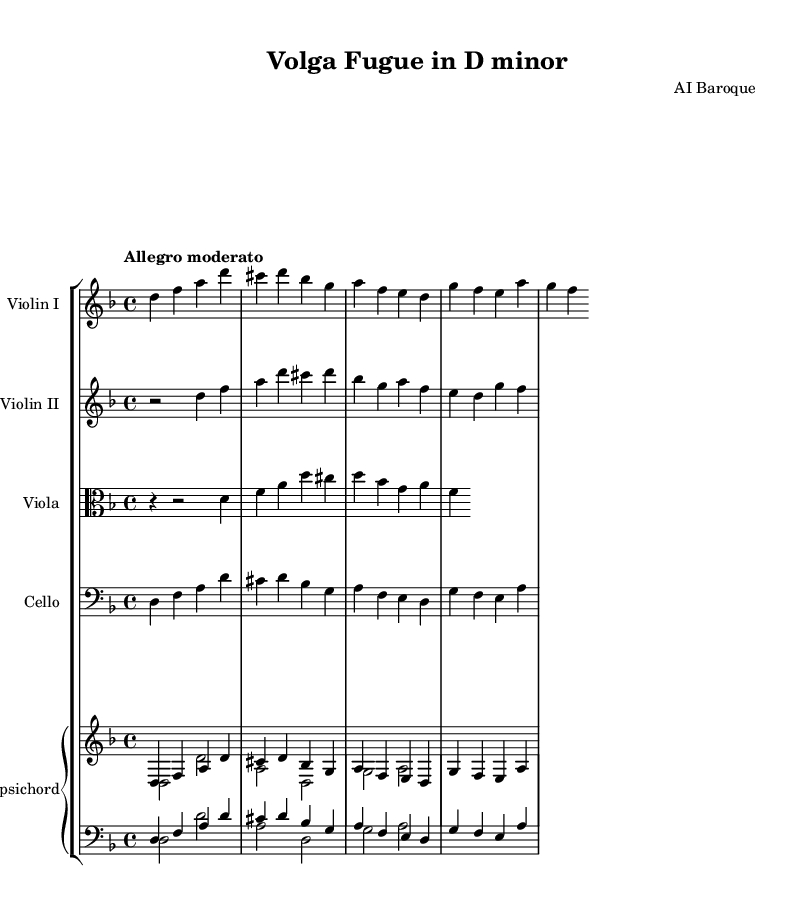What is the key signature of this music? The key signature is D minor, which has one flat (B♭). This can be determined by looking at the key signature indicated at the beginning of the score.
Answer: D minor What is the time signature of this music? The time signature is 4/4, which means there are four beats in a measure and the quarter note gets one beat. This is visible in the upper left corner of the staff.
Answer: 4/4 What is the tempo marking of this piece? The tempo marking is "Allegro moderato," which indicates a moderately fast tempo. This marking is typically placed at the beginning of the piece, indicating how the music should be played.
Answer: Allegro moderato How many staves are used for the violins? There are two staves used for the violins (Violin I and Violin II). The score clearly shows separate staves for each violin part, making it easy to differentiate between them.
Answer: Two Which instrument plays the bass line? The cello plays the bass line, as indicated by the instrumentation and the clef used (bass clef). The cello part is written in a lower range compared to the other instruments.
Answer: Cello Where is the first appearance of the note D in the violin I part? The first appearance of the note D in the Violin I part occurs on the first beat of measure one. This requires counting the measures and beats from the start of the piece.
Answer: Measure one What type of piece is this, based on the instrumentation and style? This piece is a fugue, characterized by its polyphonic texture and the use of counterpoint, typical of the Baroque style. The structure and interweaving lines reflect the characteristics of Baroque compositions.
Answer: Fugue 